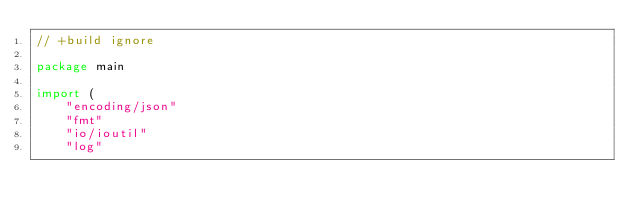Convert code to text. <code><loc_0><loc_0><loc_500><loc_500><_Go_>// +build ignore

package main

import (
	"encoding/json"
	"fmt"
	"io/ioutil"
	"log"</code> 